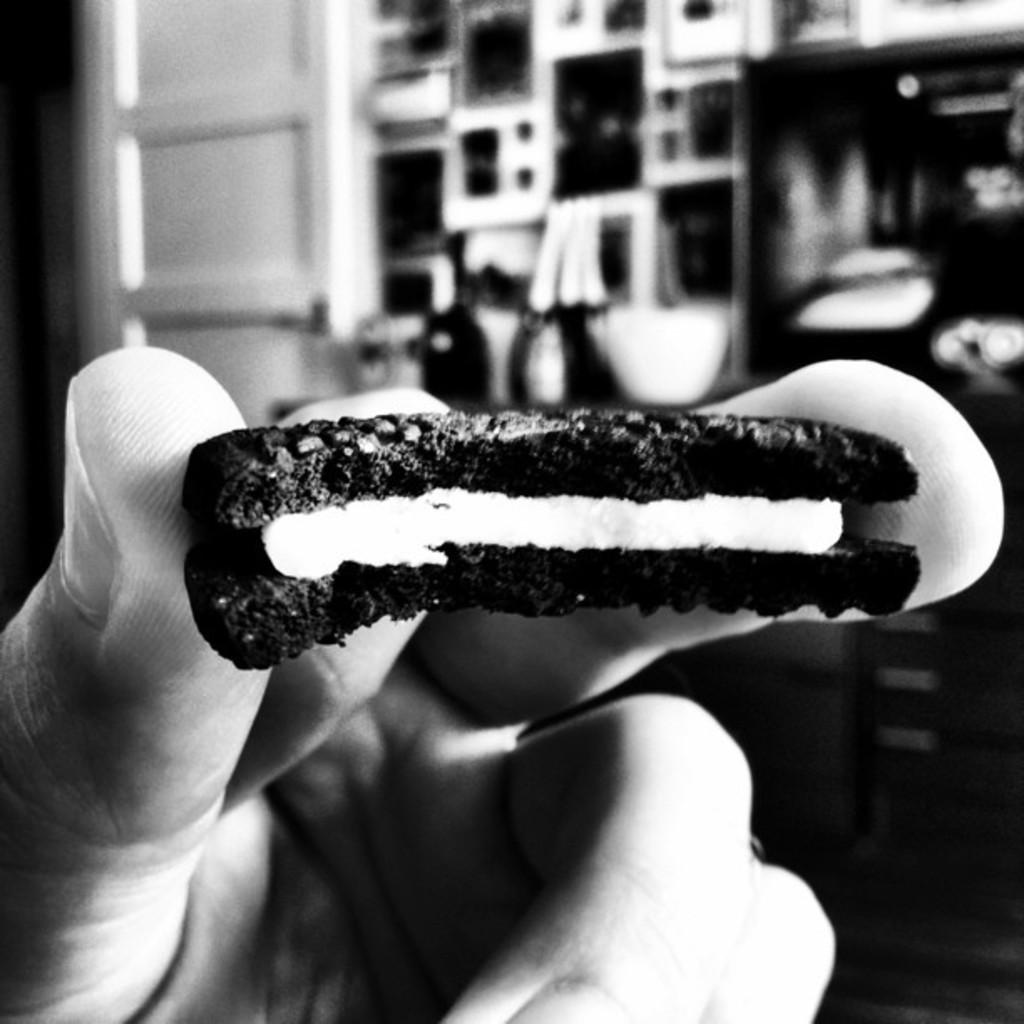What part of a person's body is visible in the center of the image? There is a person's hand visible in the center of the image. What is the person holding in their hand? The person is holding a biscuit. What type of structure can be seen in the background of the image? There is a door in the background of the image. Can you describe any other objects visible in the background? Yes, there are objects visible in the background of the image. What type of alarm is going off in the image? There is no alarm present in the image. Is there a bear visible in the image? No, there is no bear visible in the image. 